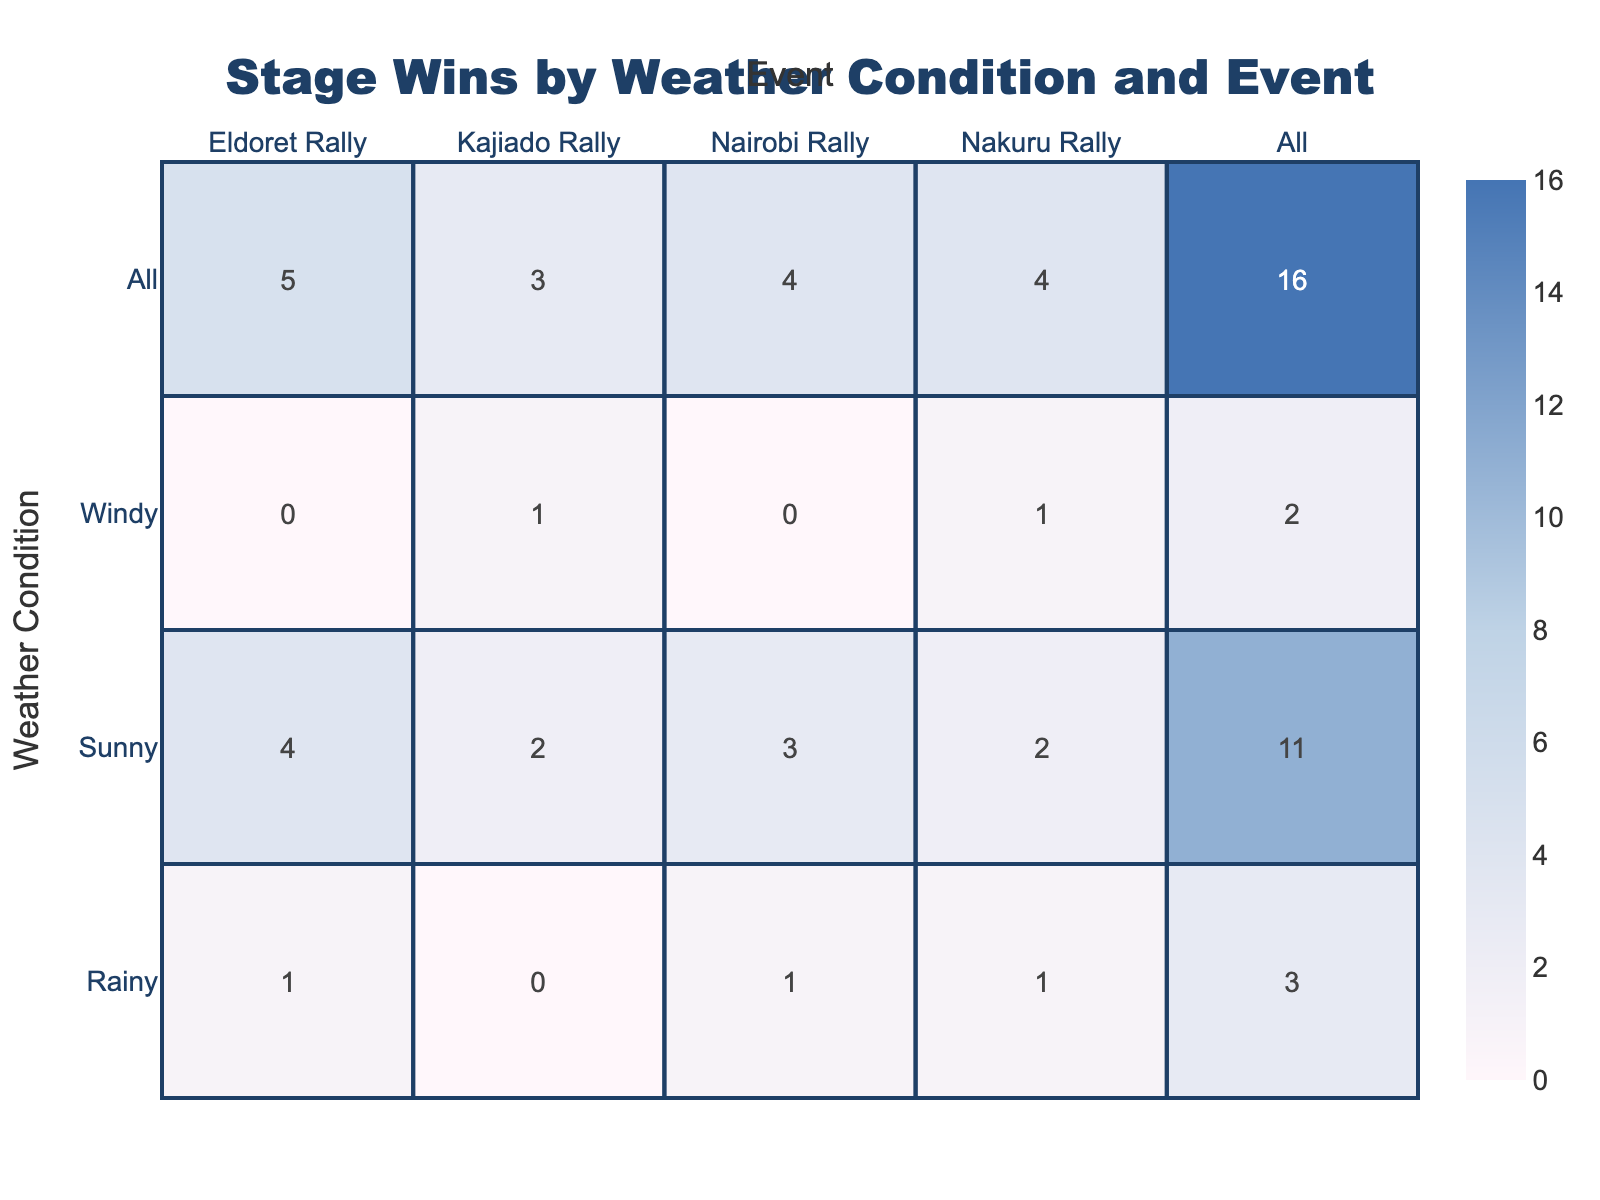What is the total number of stage wins for events held in sunny weather? Looking at the table, I sum the stage wins for all events where the weather condition is sunny. The stage wins are: Nairobi Rally (3) + Nakuru Rally (2) + Kajiado Rally (2) + Eldoret Rally (4) = 11.
Answer: 11 Which driver had the best finishing position in the rainy conditions? From the table, I identify the finishing positions of drivers under rainy conditions: Lilian Akinyi (5), Miriam Wanjiru (6), and Patricia Nyambura (8). The best finishing position is 5 by Lilian Akinyi.
Answer: 5 Did any driver win a stage in windy weather during the Kajiado Rally? Checking the table, in the Kajiado Rally under windy conditions, Gatimu Ngoya has 1 stage win, which confirms that yes, a driver did win a stage.
Answer: Yes What is the average finishing position of drivers under rainy conditions across all events? First, I gather the finishing positions for rainy conditions: Lilian Akinyi (5), Miriam Wanjiru (6), and Patricia Nyambura (8). The average is (5 + 6 + 8) / 3 = 19 / 3 = 6.33.
Answer: 6.33 In how many events did drivers win more than 2 stages in total when conditions were sunny? Analyzing the table for sunny conditions, I look at the stage wins: Nairobi Rally (3), Nakuru Rally (2), Kajiado Rally (2), and Eldoret Rally (4). Only Eldoret Rally exceeds 2 stages. Thus, it occurred in 1 event.
Answer: 1 How many drivers had a finishing position in the top 3 under windy conditions? I check the table for windy conditions: Kevin Mwangi (7) at Nairobi Rally, Benson Njoroge (4) at Nakuru Rally, and Gatimu Ngoya (5) at Kajiado Rally, and Samuel Mutai (6) at Eldoret Rally. None finished in the top 3, which means 0 drivers.
Answer: 0 Is there a weather condition where a driver consistently finished within the top 4 positions across all events? Analyzing the table for each weather condition, only for sunny does a driver finish consistently high: Jones Muriuki (1) in Nairobi Rally and Moses Chege (1) in Eldoret Rally. Thus, the weather condition is sunny, with at least 2 instances of top 4 finishes.
Answer: Yes What was the total number of stage wins across all events for each weather condition? I sum stage wins for each condition: Sunny (3 + 2 + 2 + 4) = 11, Rainy (5 + 6 + 8) = 19, Windy (0 + 1 + 1) = 2. Overall, the totals are: Sunny 11, Rainy 19, Windy 2.
Answer: Sunny 11, Rainy 19, Windy 2 